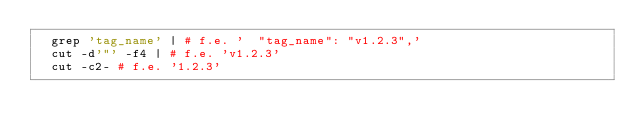<code> <loc_0><loc_0><loc_500><loc_500><_Bash_>	grep 'tag_name' | # f.e. '  "tag_name": "v1.2.3",'
	cut -d'"' -f4 | # f.e. 'v1.2.3'
	cut -c2- # f.e. '1.2.3'
</code> 